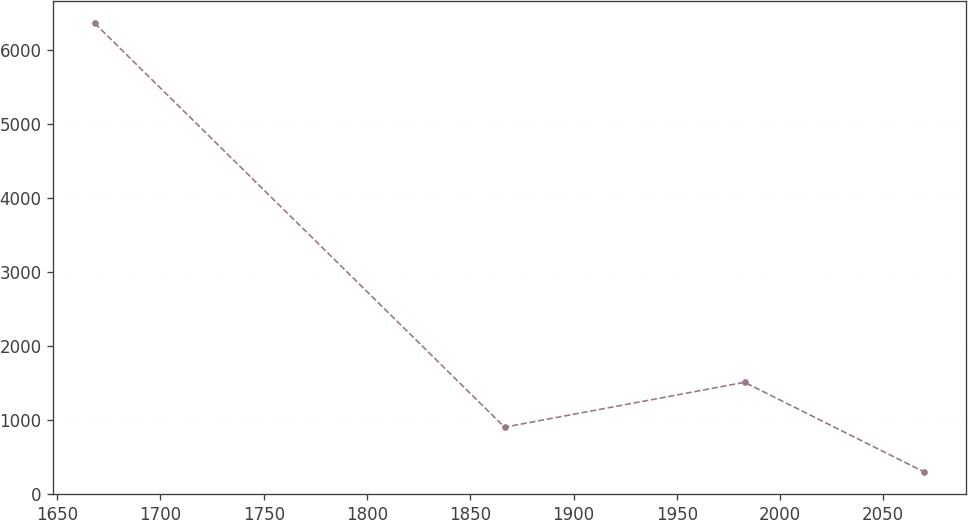<chart> <loc_0><loc_0><loc_500><loc_500><line_chart><ecel><fcel>Unnamed: 1<nl><fcel>1668.15<fcel>6363.86<nl><fcel>1866.61<fcel>898.99<nl><fcel>1982.83<fcel>1506.2<nl><fcel>2069.89<fcel>291.78<nl></chart> 